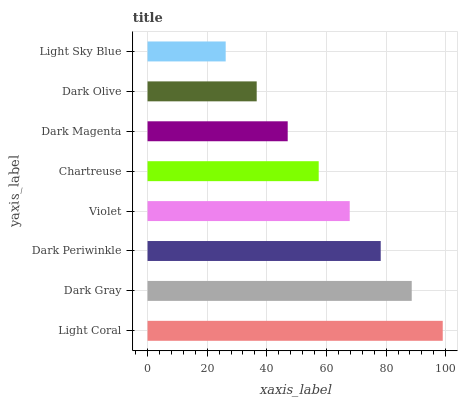Is Light Sky Blue the minimum?
Answer yes or no. Yes. Is Light Coral the maximum?
Answer yes or no. Yes. Is Dark Gray the minimum?
Answer yes or no. No. Is Dark Gray the maximum?
Answer yes or no. No. Is Light Coral greater than Dark Gray?
Answer yes or no. Yes. Is Dark Gray less than Light Coral?
Answer yes or no. Yes. Is Dark Gray greater than Light Coral?
Answer yes or no. No. Is Light Coral less than Dark Gray?
Answer yes or no. No. Is Violet the high median?
Answer yes or no. Yes. Is Chartreuse the low median?
Answer yes or no. Yes. Is Dark Magenta the high median?
Answer yes or no. No. Is Dark Gray the low median?
Answer yes or no. No. 